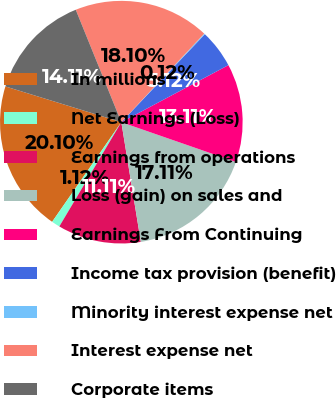<chart> <loc_0><loc_0><loc_500><loc_500><pie_chart><fcel>In millions<fcel>Net Earnings (Loss)<fcel>Earnings from operations<fcel>Loss (gain) on sales and<fcel>Earnings From Continuing<fcel>Income tax provision (benefit)<fcel>Minority interest expense net<fcel>Interest expense net<fcel>Corporate items<nl><fcel>20.1%<fcel>1.12%<fcel>11.11%<fcel>17.11%<fcel>13.11%<fcel>5.12%<fcel>0.12%<fcel>18.1%<fcel>14.11%<nl></chart> 